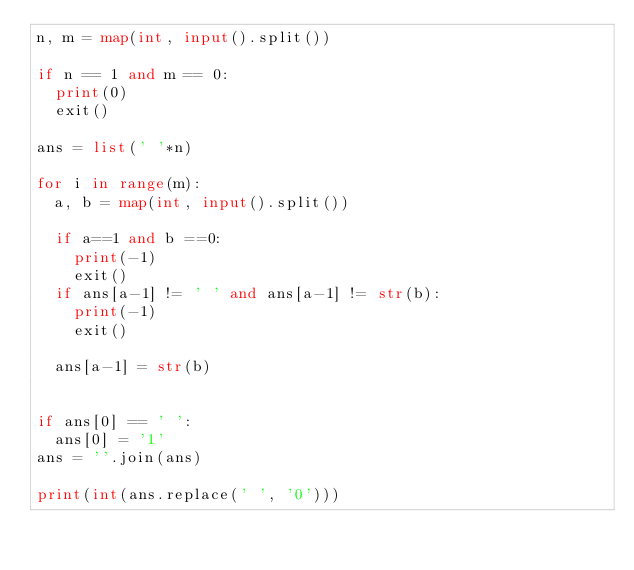Convert code to text. <code><loc_0><loc_0><loc_500><loc_500><_Python_>n, m = map(int, input().split())

if n == 1 and m == 0:
  print(0)
  exit()
  
ans = list(' '*n)

for i in range(m):
  a, b = map(int, input().split())
  
  if a==1 and b ==0:
    print(-1)
    exit()
  if ans[a-1] != ' ' and ans[a-1] != str(b):
    print(-1)
    exit()
    
  ans[a-1] = str(b)


if ans[0] == ' ':
  ans[0] = '1'
ans = ''.join(ans)

print(int(ans.replace(' ', '0')))
</code> 